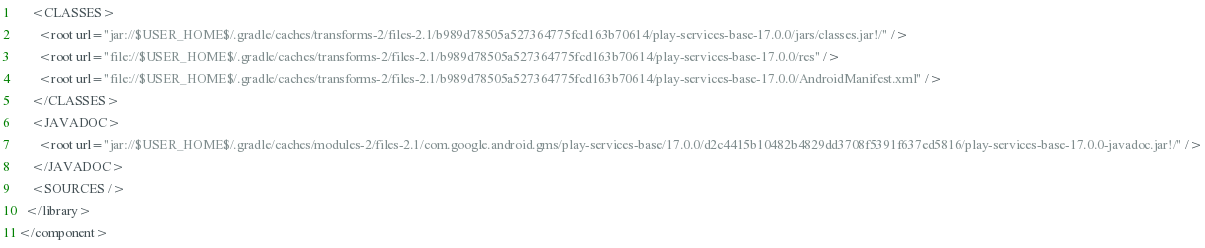Convert code to text. <code><loc_0><loc_0><loc_500><loc_500><_XML_>    <CLASSES>
      <root url="jar://$USER_HOME$/.gradle/caches/transforms-2/files-2.1/b989d78505a527364775fcd163b70614/play-services-base-17.0.0/jars/classes.jar!/" />
      <root url="file://$USER_HOME$/.gradle/caches/transforms-2/files-2.1/b989d78505a527364775fcd163b70614/play-services-base-17.0.0/res" />
      <root url="file://$USER_HOME$/.gradle/caches/transforms-2/files-2.1/b989d78505a527364775fcd163b70614/play-services-base-17.0.0/AndroidManifest.xml" />
    </CLASSES>
    <JAVADOC>
      <root url="jar://$USER_HOME$/.gradle/caches/modules-2/files-2.1/com.google.android.gms/play-services-base/17.0.0/d2c4415b10482b4829dd3708f5391f637ed5816/play-services-base-17.0.0-javadoc.jar!/" />
    </JAVADOC>
    <SOURCES />
  </library>
</component></code> 